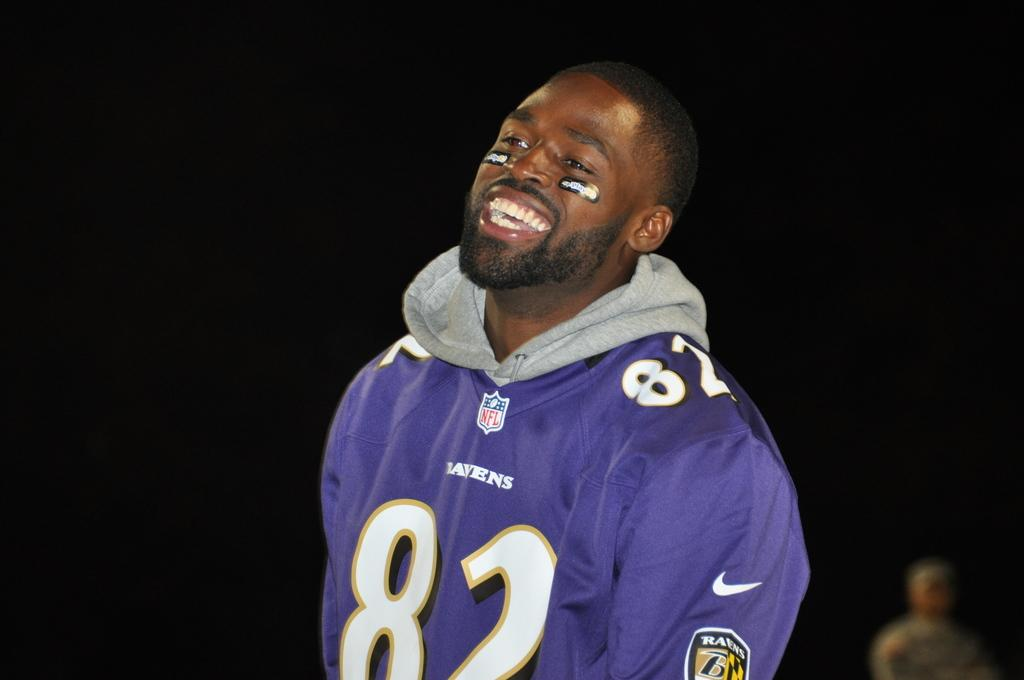<image>
Summarize the visual content of the image. A man is wearing a purple jersey with the number 82 on it. 